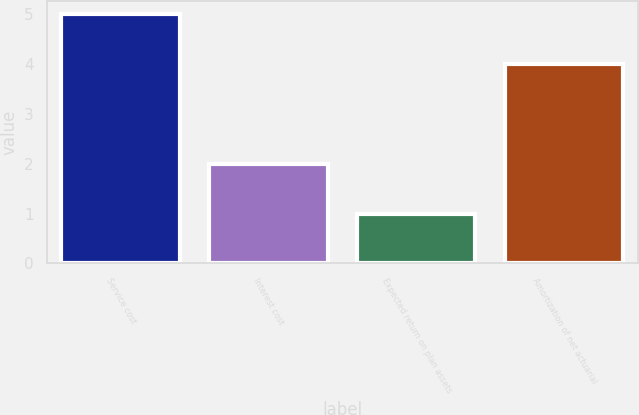Convert chart to OTSL. <chart><loc_0><loc_0><loc_500><loc_500><bar_chart><fcel>Service cost<fcel>Interest cost<fcel>Expected return on plan assets<fcel>Amortization of net actuarial<nl><fcel>5<fcel>2<fcel>1<fcel>4<nl></chart> 